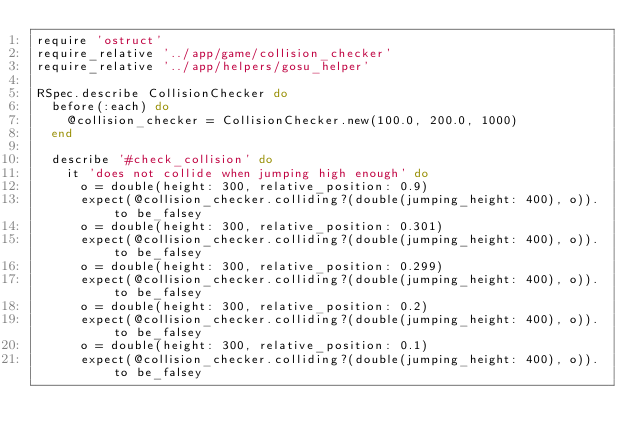Convert code to text. <code><loc_0><loc_0><loc_500><loc_500><_Ruby_>require 'ostruct'
require_relative '../app/game/collision_checker'
require_relative '../app/helpers/gosu_helper'

RSpec.describe CollisionChecker do
  before(:each) do
    @collision_checker = CollisionChecker.new(100.0, 200.0, 1000)
  end

  describe '#check_collision' do
    it 'does not collide when jumping high enough' do
      o = double(height: 300, relative_position: 0.9)
      expect(@collision_checker.colliding?(double(jumping_height: 400), o)).to be_falsey
      o = double(height: 300, relative_position: 0.301)
      expect(@collision_checker.colliding?(double(jumping_height: 400), o)).to be_falsey
      o = double(height: 300, relative_position: 0.299)
      expect(@collision_checker.colliding?(double(jumping_height: 400), o)).to be_falsey
      o = double(height: 300, relative_position: 0.2)
      expect(@collision_checker.colliding?(double(jumping_height: 400), o)).to be_falsey
      o = double(height: 300, relative_position: 0.1)
      expect(@collision_checker.colliding?(double(jumping_height: 400), o)).to be_falsey</code> 